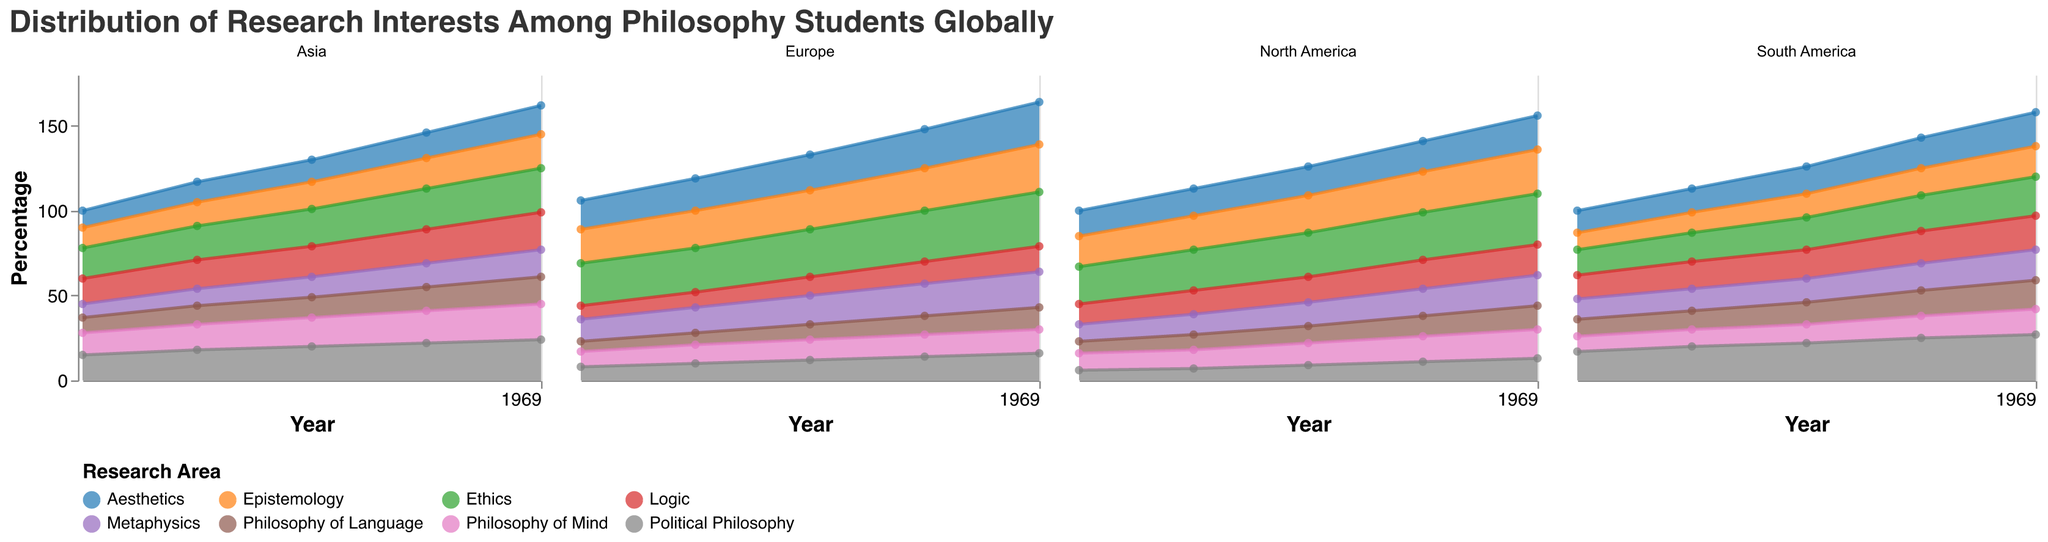What is the title of the figure? The title is found at the top of the figure, usually in a larger or bold font for emphasis. It summarizes the content of the chart.
Answer: Distribution of Research Interests Among Philosophy Students Globally How many continents are represented in the figure? Each subplot corresponds to a different continent, and the figure displays the number of these subplots.
Answer: 4 Which continent had the highest interest in Ethics in 2022? Identify the subplot for each continent for 2022, then compare the height of the areas representing Ethics across these subplots.
Answer: Europe What is the overall trend in interest in Political Philosophy in South America from 2018 to 2022? Look at the subplot for South America and observe the changes in the area representing Political Philosophy from 2018 to 2022.
Answer: Increasing Between 2018 and 2022, did the interest in Logic in Asia always increase, decrease, or fluctuate? Examine the subplot for Asia and trace the area representing Logic values from each year. Note if the values consistently go up, down, or both.
Answer: Increase Which research area saw a significant rise in interest in North America from 2018 to 2022? Look at the North America subplot and compare the areas of all research interests between these years, focusing on which had the most noticeable rise.
Answer: Ethics In Europe, which year showed the highest combined interest in Ethics and Epistemology? For the Europe subplot, add the values of Ethics and Epistemology for each year, then identify the year with the highest sum.
Answer: 2022 Compare the interest in Metaphysics between Europe and Asia in 2020. Which had higher interest? Examine the areas representing Metaphysics in the Europe and Asia subplots for 2020; compare their heights.
Answer: Europe Did the interest in Aesthetics in South America increase more rapidly or more slowly compared to Political Philosophy between 2018 and 2022? Observe the slopes of the areas for Aesthetics and Political Philosophy. Steeper slopes indicate faster increases.
Answer: More slowly 